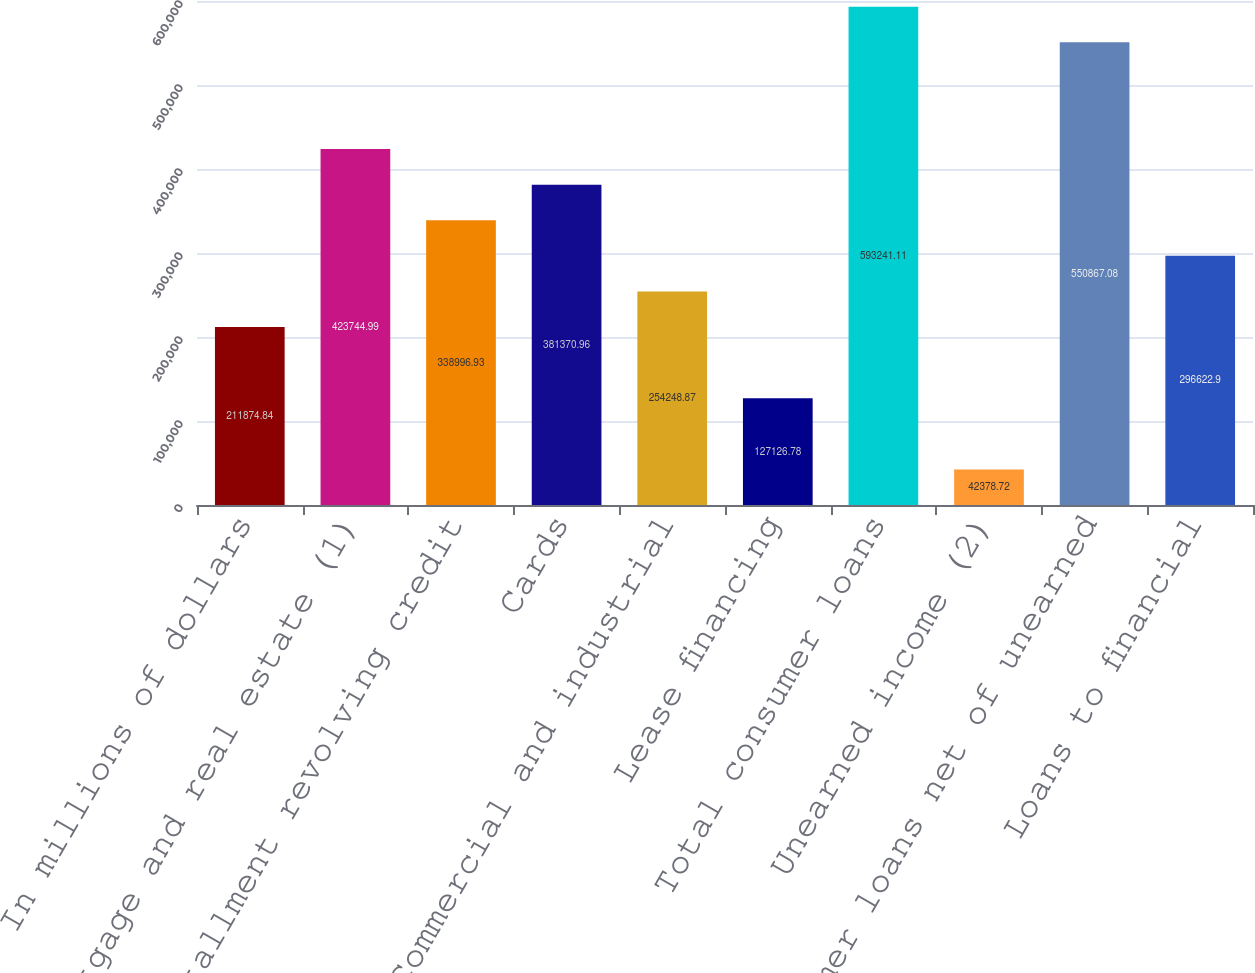<chart> <loc_0><loc_0><loc_500><loc_500><bar_chart><fcel>In millions of dollars<fcel>Mortgage and real estate (1)<fcel>Installment revolving credit<fcel>Cards<fcel>Commercial and industrial<fcel>Lease financing<fcel>Total consumer loans<fcel>Unearned income (2)<fcel>Consumer loans net of unearned<fcel>Loans to financial<nl><fcel>211875<fcel>423745<fcel>338997<fcel>381371<fcel>254249<fcel>127127<fcel>593241<fcel>42378.7<fcel>550867<fcel>296623<nl></chart> 